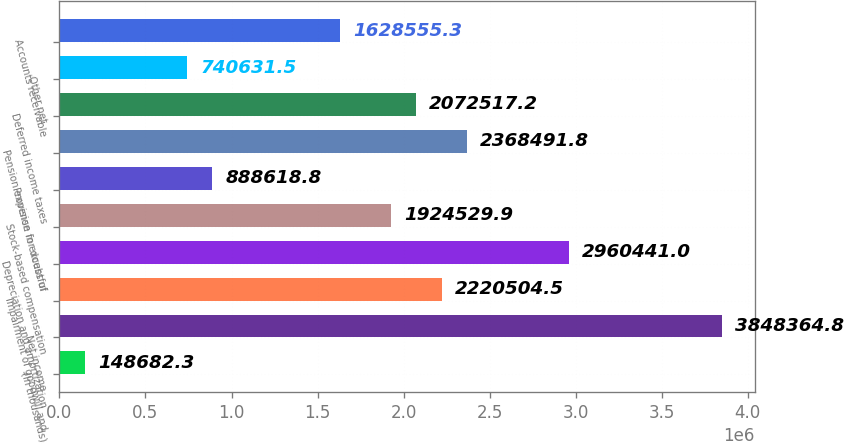<chart> <loc_0><loc_0><loc_500><loc_500><bar_chart><fcel>(In thousands)<fcel>Net income<fcel>Impairment of goodwill and<fcel>Depreciation and amortization<fcel>Stock-based compensation<fcel>Provision for doubtful<fcel>Pension expense in excess of<fcel>Deferred income taxes<fcel>Other net<fcel>Accounts receivable<nl><fcel>148682<fcel>3.84836e+06<fcel>2.2205e+06<fcel>2.96044e+06<fcel>1.92453e+06<fcel>888619<fcel>2.36849e+06<fcel>2.07252e+06<fcel>740632<fcel>1.62856e+06<nl></chart> 